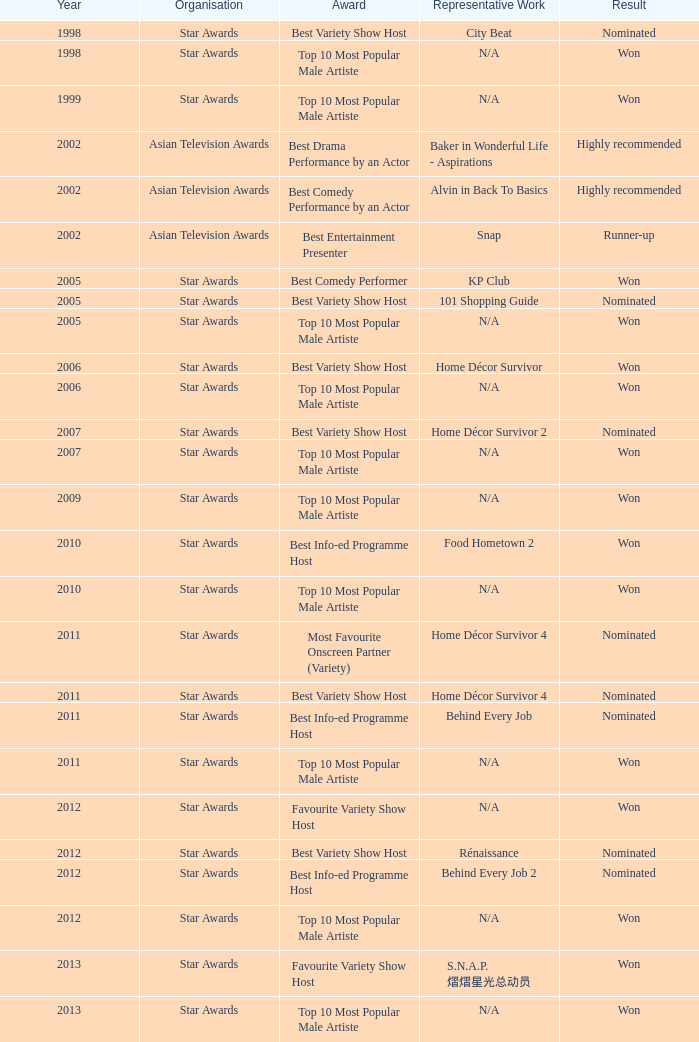For an award in a year later than 2005, what is its name and the status of the nomination? Best Variety Show Host, Most Favourite Onscreen Partner (Variety), Best Variety Show Host, Best Info-ed Programme Host, Best Variety Show Host, Best Info-ed Programme Host, Best Info-Ed Programme Host, Best Variety Show Host. 